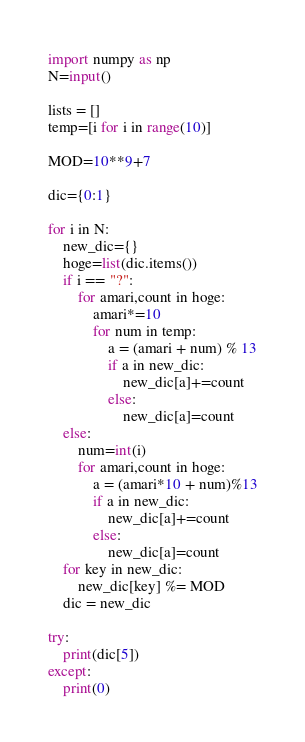<code> <loc_0><loc_0><loc_500><loc_500><_Python_>import numpy as np
N=input()

lists = []
temp=[i for i in range(10)]

MOD=10**9+7

dic={0:1}

for i in N:
    new_dic={}
    hoge=list(dic.items())
    if i == "?":
        for amari,count in hoge:
            amari*=10
            for num in temp:
                a = (amari + num) % 13
                if a in new_dic:
                    new_dic[a]+=count
                else:
                    new_dic[a]=count
    else:
        num=int(i)
        for amari,count in hoge:
            a = (amari*10 + num)%13
            if a in new_dic:
                new_dic[a]+=count
            else:
                new_dic[a]=count
    for key in new_dic:
        new_dic[key] %= MOD
    dic = new_dic

try:
    print(dic[5])
except:
    print(0)</code> 